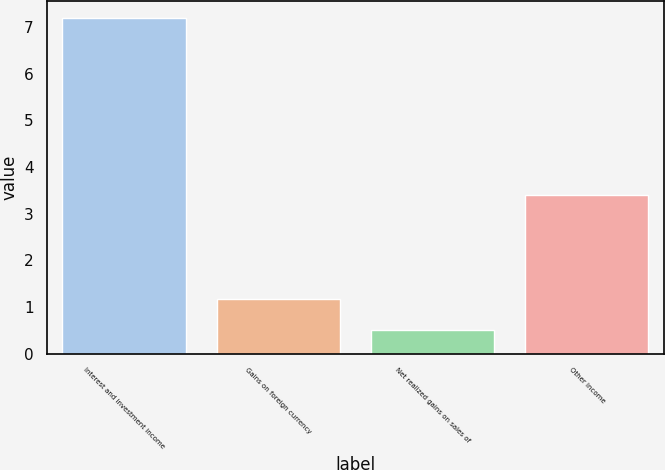<chart> <loc_0><loc_0><loc_500><loc_500><bar_chart><fcel>Interest and investment income<fcel>Gains on foreign currency<fcel>Net realized gains on sales of<fcel>Other income<nl><fcel>7.2<fcel>1.17<fcel>0.5<fcel>3.4<nl></chart> 